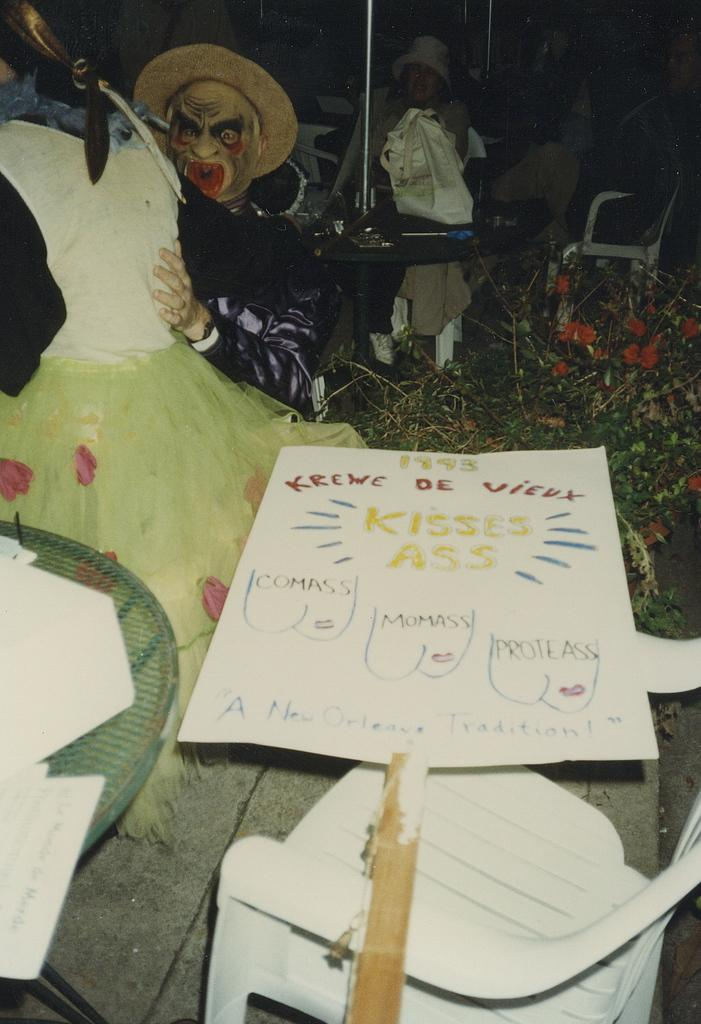<image>
Give a short and clear explanation of the subsequent image. Tabletop with a white card and red words that say "Krewe De Vieux". 